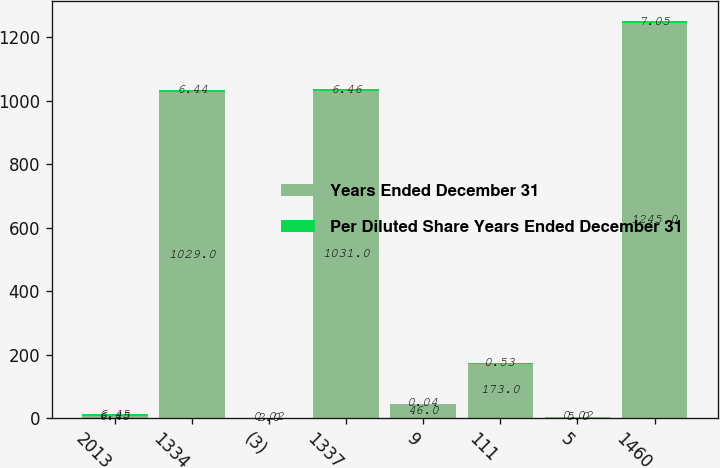<chart> <loc_0><loc_0><loc_500><loc_500><stacked_bar_chart><ecel><fcel>2013<fcel>1334<fcel>(3)<fcel>1337<fcel>9<fcel>111<fcel>5<fcel>1460<nl><fcel>Years Ended December 31<fcel>6.45<fcel>1029<fcel>2<fcel>1031<fcel>46<fcel>173<fcel>5<fcel>1245<nl><fcel>Per Diluted Share Years Ended December 31<fcel>6.45<fcel>6.44<fcel>0.02<fcel>6.46<fcel>0.04<fcel>0.53<fcel>0.02<fcel>7.05<nl></chart> 